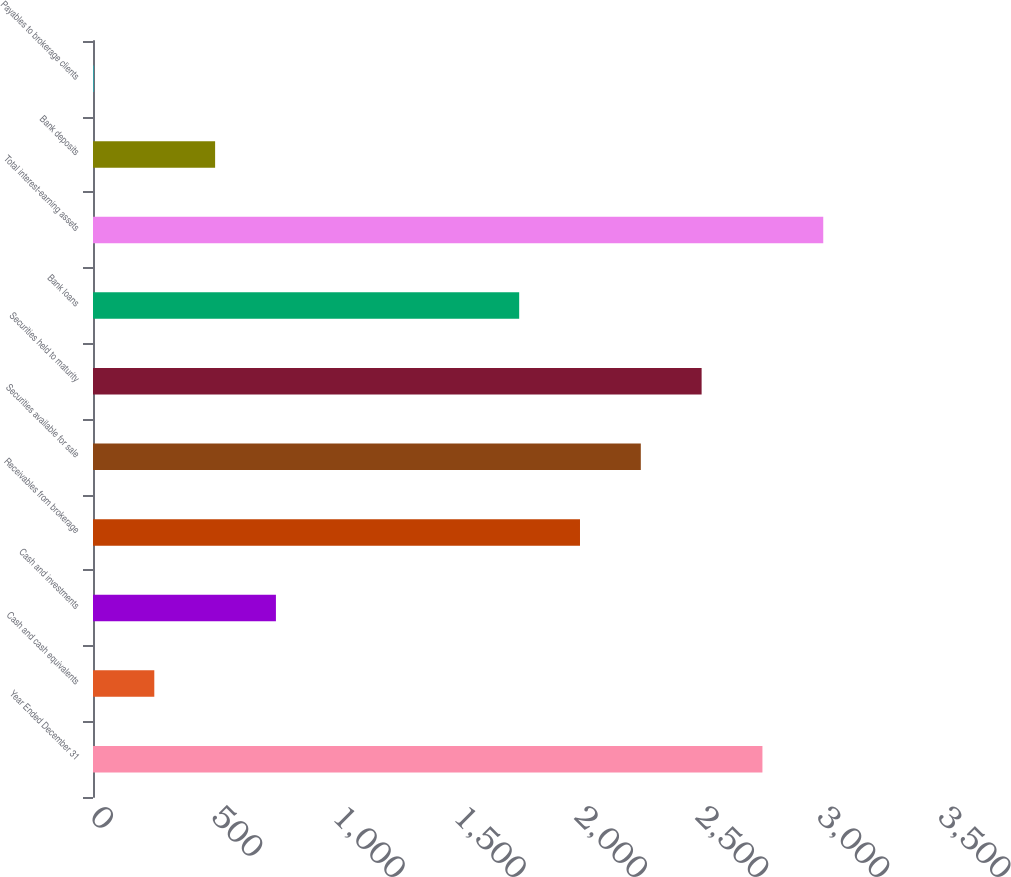Convert chart to OTSL. <chart><loc_0><loc_0><loc_500><loc_500><bar_chart><fcel>Year Ended December 31<fcel>Cash and cash equivalents<fcel>Cash and investments<fcel>Receivables from brokerage<fcel>Securities available for sale<fcel>Securities held to maturity<fcel>Bank loans<fcel>Total interest-earning assets<fcel>Bank deposits<fcel>Payables to brokerage clients<nl><fcel>2763<fcel>253<fcel>755<fcel>2010<fcel>2261<fcel>2512<fcel>1759<fcel>3014<fcel>504<fcel>2<nl></chart> 